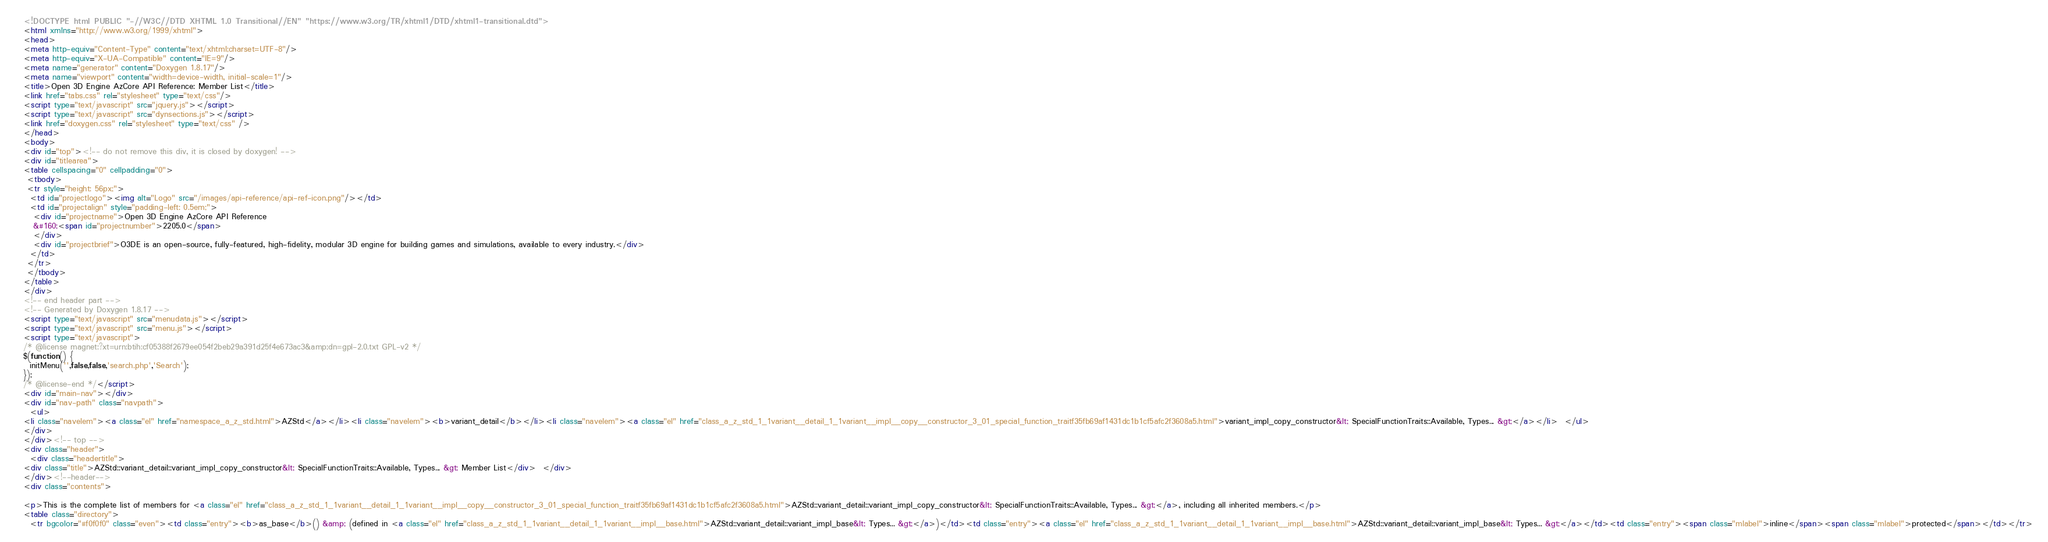Convert code to text. <code><loc_0><loc_0><loc_500><loc_500><_HTML_><!DOCTYPE html PUBLIC "-//W3C//DTD XHTML 1.0 Transitional//EN" "https://www.w3.org/TR/xhtml1/DTD/xhtml1-transitional.dtd">
<html xmlns="http://www.w3.org/1999/xhtml">
<head>
<meta http-equiv="Content-Type" content="text/xhtml;charset=UTF-8"/>
<meta http-equiv="X-UA-Compatible" content="IE=9"/>
<meta name="generator" content="Doxygen 1.8.17"/>
<meta name="viewport" content="width=device-width, initial-scale=1"/>
<title>Open 3D Engine AzCore API Reference: Member List</title>
<link href="tabs.css" rel="stylesheet" type="text/css"/>
<script type="text/javascript" src="jquery.js"></script>
<script type="text/javascript" src="dynsections.js"></script>
<link href="doxygen.css" rel="stylesheet" type="text/css" />
</head>
<body>
<div id="top"><!-- do not remove this div, it is closed by doxygen! -->
<div id="titlearea">
<table cellspacing="0" cellpadding="0">
 <tbody>
 <tr style="height: 56px;">
  <td id="projectlogo"><img alt="Logo" src="/images/api-reference/api-ref-icon.png"/></td>
  <td id="projectalign" style="padding-left: 0.5em;">
   <div id="projectname">Open 3D Engine AzCore API Reference
   &#160;<span id="projectnumber">2205.0</span>
   </div>
   <div id="projectbrief">O3DE is an open-source, fully-featured, high-fidelity, modular 3D engine for building games and simulations, available to every industry.</div>
  </td>
 </tr>
 </tbody>
</table>
</div>
<!-- end header part -->
<!-- Generated by Doxygen 1.8.17 -->
<script type="text/javascript" src="menudata.js"></script>
<script type="text/javascript" src="menu.js"></script>
<script type="text/javascript">
/* @license magnet:?xt=urn:btih:cf05388f2679ee054f2beb29a391d25f4e673ac3&amp;dn=gpl-2.0.txt GPL-v2 */
$(function() {
  initMenu('',false,false,'search.php','Search');
});
/* @license-end */</script>
<div id="main-nav"></div>
<div id="nav-path" class="navpath">
  <ul>
<li class="navelem"><a class="el" href="namespace_a_z_std.html">AZStd</a></li><li class="navelem"><b>variant_detail</b></li><li class="navelem"><a class="el" href="class_a_z_std_1_1variant__detail_1_1variant__impl__copy__constructor_3_01_special_function_traitf35fb69af1431dc1b1cf5afc2f3608a5.html">variant_impl_copy_constructor&lt; SpecialFunctionTraits::Available, Types... &gt;</a></li>  </ul>
</div>
</div><!-- top -->
<div class="header">
  <div class="headertitle">
<div class="title">AZStd::variant_detail::variant_impl_copy_constructor&lt; SpecialFunctionTraits::Available, Types... &gt; Member List</div>  </div>
</div><!--header-->
<div class="contents">

<p>This is the complete list of members for <a class="el" href="class_a_z_std_1_1variant__detail_1_1variant__impl__copy__constructor_3_01_special_function_traitf35fb69af1431dc1b1cf5afc2f3608a5.html">AZStd::variant_detail::variant_impl_copy_constructor&lt; SpecialFunctionTraits::Available, Types... &gt;</a>, including all inherited members.</p>
<table class="directory">
  <tr bgcolor="#f0f0f0" class="even"><td class="entry"><b>as_base</b>() &amp; (defined in <a class="el" href="class_a_z_std_1_1variant__detail_1_1variant__impl__base.html">AZStd::variant_detail::variant_impl_base&lt; Types... &gt;</a>)</td><td class="entry"><a class="el" href="class_a_z_std_1_1variant__detail_1_1variant__impl__base.html">AZStd::variant_detail::variant_impl_base&lt; Types... &gt;</a></td><td class="entry"><span class="mlabel">inline</span><span class="mlabel">protected</span></td></tr></code> 